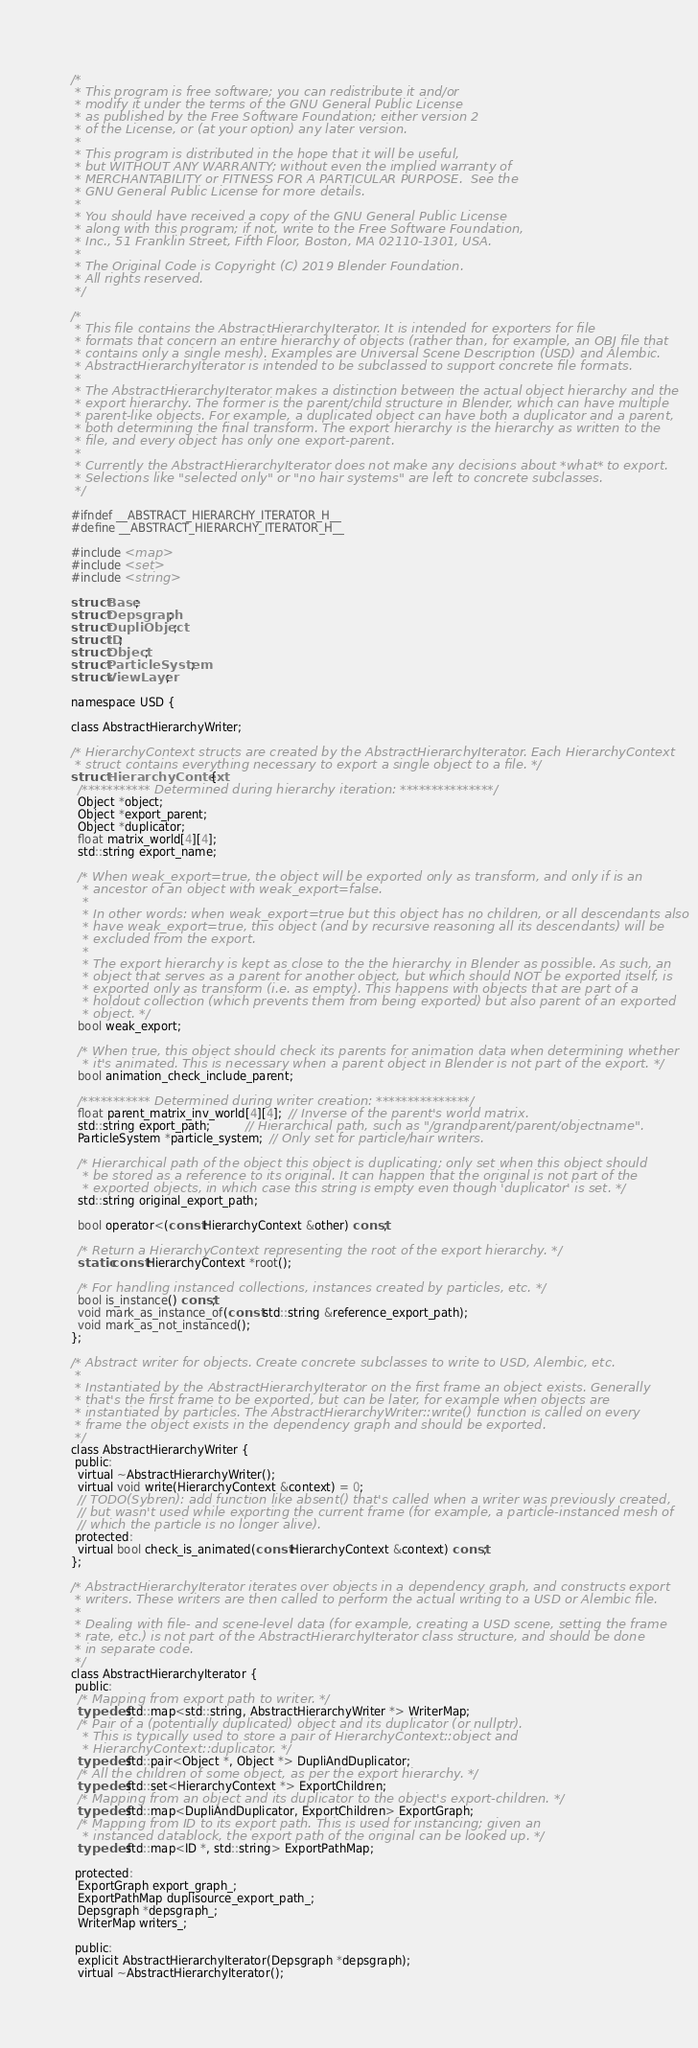Convert code to text. <code><loc_0><loc_0><loc_500><loc_500><_C_>/*
 * This program is free software; you can redistribute it and/or
 * modify it under the terms of the GNU General Public License
 * as published by the Free Software Foundation; either version 2
 * of the License, or (at your option) any later version.
 *
 * This program is distributed in the hope that it will be useful,
 * but WITHOUT ANY WARRANTY; without even the implied warranty of
 * MERCHANTABILITY or FITNESS FOR A PARTICULAR PURPOSE.  See the
 * GNU General Public License for more details.
 *
 * You should have received a copy of the GNU General Public License
 * along with this program; if not, write to the Free Software Foundation,
 * Inc., 51 Franklin Street, Fifth Floor, Boston, MA 02110-1301, USA.
 *
 * The Original Code is Copyright (C) 2019 Blender Foundation.
 * All rights reserved.
 */

/*
 * This file contains the AbstractHierarchyIterator. It is intended for exporters for file
 * formats that concern an entire hierarchy of objects (rather than, for example, an OBJ file that
 * contains only a single mesh). Examples are Universal Scene Description (USD) and Alembic.
 * AbstractHierarchyIterator is intended to be subclassed to support concrete file formats.
 *
 * The AbstractHierarchyIterator makes a distinction between the actual object hierarchy and the
 * export hierarchy. The former is the parent/child structure in Blender, which can have multiple
 * parent-like objects. For example, a duplicated object can have both a duplicator and a parent,
 * both determining the final transform. The export hierarchy is the hierarchy as written to the
 * file, and every object has only one export-parent.
 *
 * Currently the AbstractHierarchyIterator does not make any decisions about *what* to export.
 * Selections like "selected only" or "no hair systems" are left to concrete subclasses.
 */

#ifndef __ABSTRACT_HIERARCHY_ITERATOR_H__
#define __ABSTRACT_HIERARCHY_ITERATOR_H__

#include <map>
#include <set>
#include <string>

struct Base;
struct Depsgraph;
struct DupliObject;
struct ID;
struct Object;
struct ParticleSystem;
struct ViewLayer;

namespace USD {

class AbstractHierarchyWriter;

/* HierarchyContext structs are created by the AbstractHierarchyIterator. Each HierarchyContext
 * struct contains everything necessary to export a single object to a file. */
struct HierarchyContext {
  /*********** Determined during hierarchy iteration: ***************/
  Object *object;
  Object *export_parent;
  Object *duplicator;
  float matrix_world[4][4];
  std::string export_name;

  /* When weak_export=true, the object will be exported only as transform, and only if is an
   * ancestor of an object with weak_export=false.
   *
   * In other words: when weak_export=true but this object has no children, or all descendants also
   * have weak_export=true, this object (and by recursive reasoning all its descendants) will be
   * excluded from the export.
   *
   * The export hierarchy is kept as close to the the hierarchy in Blender as possible. As such, an
   * object that serves as a parent for another object, but which should NOT be exported itself, is
   * exported only as transform (i.e. as empty). This happens with objects that are part of a
   * holdout collection (which prevents them from being exported) but also parent of an exported
   * object. */
  bool weak_export;

  /* When true, this object should check its parents for animation data when determining whether
   * it's animated. This is necessary when a parent object in Blender is not part of the export. */
  bool animation_check_include_parent;

  /*********** Determined during writer creation: ***************/
  float parent_matrix_inv_world[4][4];  // Inverse of the parent's world matrix.
  std::string export_path;          // Hierarchical path, such as "/grandparent/parent/objectname".
  ParticleSystem *particle_system;  // Only set for particle/hair writers.

  /* Hierarchical path of the object this object is duplicating; only set when this object should
   * be stored as a reference to its original. It can happen that the original is not part of the
   * exported objects, in which case this string is empty even though 'duplicator' is set. */
  std::string original_export_path;

  bool operator<(const HierarchyContext &other) const;

  /* Return a HierarchyContext representing the root of the export hierarchy. */
  static const HierarchyContext *root();

  /* For handling instanced collections, instances created by particles, etc. */
  bool is_instance() const;
  void mark_as_instance_of(const std::string &reference_export_path);
  void mark_as_not_instanced();
};

/* Abstract writer for objects. Create concrete subclasses to write to USD, Alembic, etc.
 *
 * Instantiated by the AbstractHierarchyIterator on the first frame an object exists. Generally
 * that's the first frame to be exported, but can be later, for example when objects are
 * instantiated by particles. The AbstractHierarchyWriter::write() function is called on every
 * frame the object exists in the dependency graph and should be exported.
 */
class AbstractHierarchyWriter {
 public:
  virtual ~AbstractHierarchyWriter();
  virtual void write(HierarchyContext &context) = 0;
  // TODO(Sybren): add function like absent() that's called when a writer was previously created,
  // but wasn't used while exporting the current frame (for example, a particle-instanced mesh of
  // which the particle is no longer alive).
 protected:
  virtual bool check_is_animated(const HierarchyContext &context) const;
};

/* AbstractHierarchyIterator iterates over objects in a dependency graph, and constructs export
 * writers. These writers are then called to perform the actual writing to a USD or Alembic file.
 *
 * Dealing with file- and scene-level data (for example, creating a USD scene, setting the frame
 * rate, etc.) is not part of the AbstractHierarchyIterator class structure, and should be done
 * in separate code.
 */
class AbstractHierarchyIterator {
 public:
  /* Mapping from export path to writer. */
  typedef std::map<std::string, AbstractHierarchyWriter *> WriterMap;
  /* Pair of a (potentially duplicated) object and its duplicator (or nullptr).
   * This is typically used to store a pair of HierarchyContext::object and
   * HierarchyContext::duplicator. */
  typedef std::pair<Object *, Object *> DupliAndDuplicator;
  /* All the children of some object, as per the export hierarchy. */
  typedef std::set<HierarchyContext *> ExportChildren;
  /* Mapping from an object and its duplicator to the object's export-children. */
  typedef std::map<DupliAndDuplicator, ExportChildren> ExportGraph;
  /* Mapping from ID to its export path. This is used for instancing; given an
   * instanced datablock, the export path of the original can be looked up. */
  typedef std::map<ID *, std::string> ExportPathMap;

 protected:
  ExportGraph export_graph_;
  ExportPathMap duplisource_export_path_;
  Depsgraph *depsgraph_;
  WriterMap writers_;

 public:
  explicit AbstractHierarchyIterator(Depsgraph *depsgraph);
  virtual ~AbstractHierarchyIterator();
</code> 